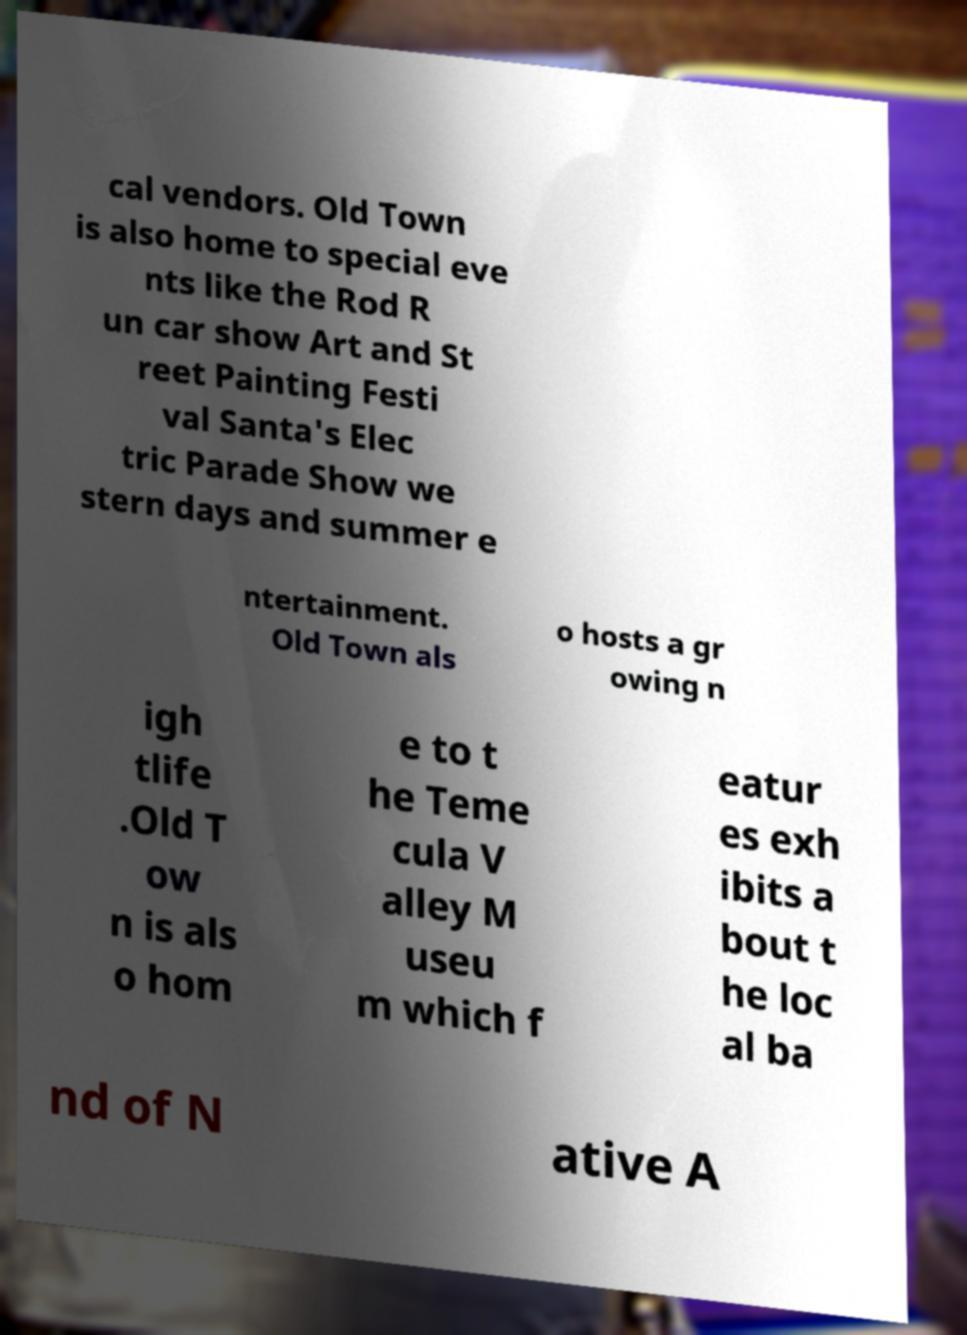Can you accurately transcribe the text from the provided image for me? cal vendors. Old Town is also home to special eve nts like the Rod R un car show Art and St reet Painting Festi val Santa's Elec tric Parade Show we stern days and summer e ntertainment. Old Town als o hosts a gr owing n igh tlife .Old T ow n is als o hom e to t he Teme cula V alley M useu m which f eatur es exh ibits a bout t he loc al ba nd of N ative A 